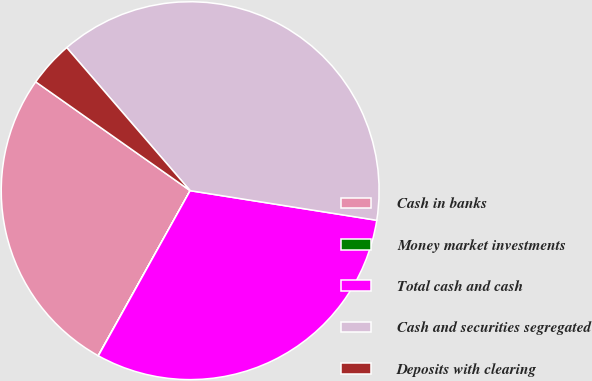Convert chart. <chart><loc_0><loc_0><loc_500><loc_500><pie_chart><fcel>Cash in banks<fcel>Money market investments<fcel>Total cash and cash<fcel>Cash and securities segregated<fcel>Deposits with clearing<nl><fcel>26.68%<fcel>0.02%<fcel>30.57%<fcel>38.84%<fcel>3.9%<nl></chart> 